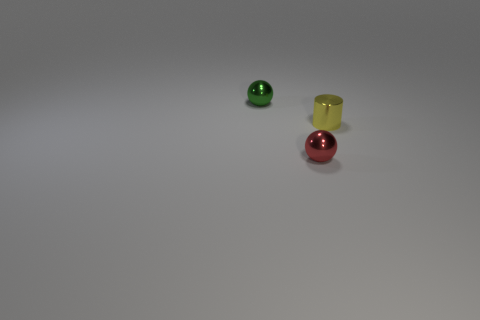There is another ball that is the same material as the red ball; what color is it? green 